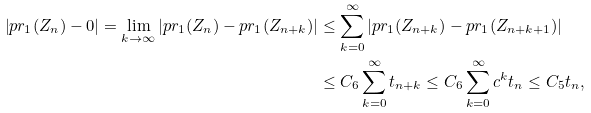Convert formula to latex. <formula><loc_0><loc_0><loc_500><loc_500>\left | p r _ { 1 } ( Z _ { n } ) - 0 \right | = \lim _ { k \to \infty } \left | p r _ { 1 } ( Z _ { n } ) - p r _ { 1 } ( Z _ { n + k } ) \right | & \leq \sum _ { k = 0 } ^ { \infty } \left | p r _ { 1 } ( Z _ { n + k } ) - p r _ { 1 } ( Z _ { n + k + 1 } ) \right | \\ & \leq C _ { 6 } \sum _ { k = 0 } ^ { \infty } t _ { n + k } \leq C _ { 6 } \sum _ { k = 0 } ^ { \infty } c ^ { k } t _ { n } \leq C _ { 5 } t _ { n } ,</formula> 